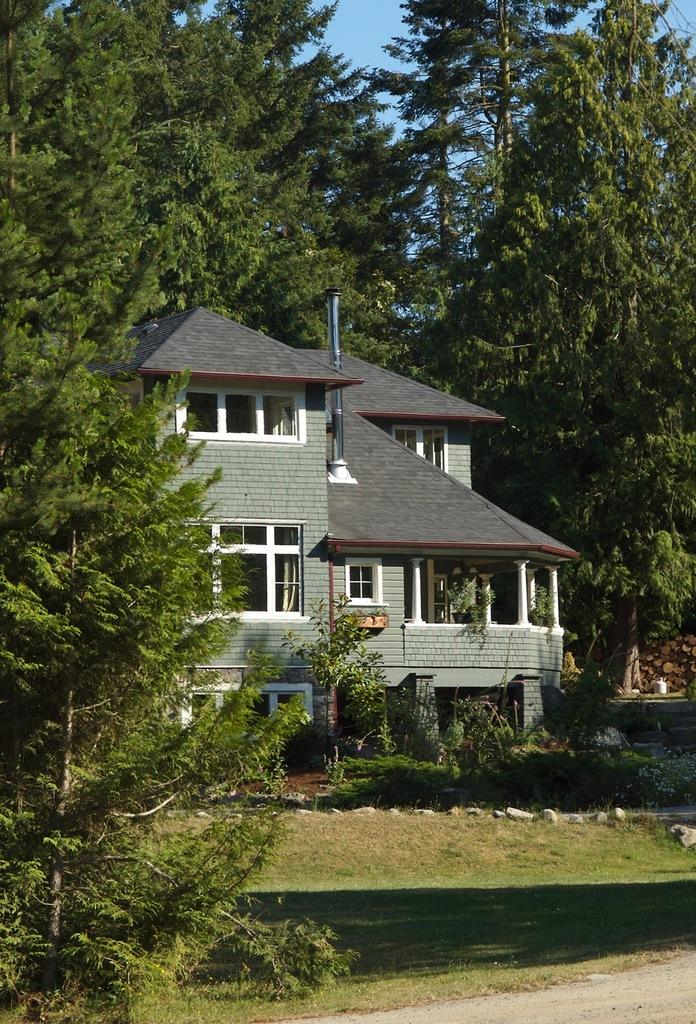What type of structure is present in the image? There is a house in the image. What other natural elements can be seen in the image? There are trees and grass visible in the image. Are there any plants in the image? Yes, there are plants in the image. What can be seen in the background of the image? The sky is visible in the background of the image. What type of notebook is being used by the stone in the image? There is no stone or notebook present in the image. 